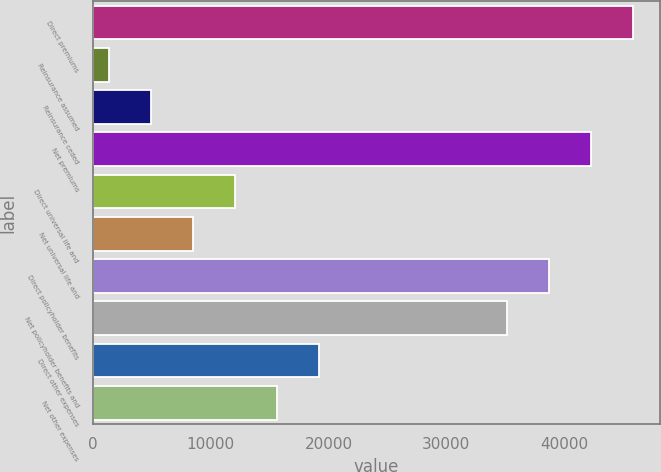Convert chart. <chart><loc_0><loc_0><loc_500><loc_500><bar_chart><fcel>Direct premiums<fcel>Reinsurance assumed<fcel>Reinsurance ceded<fcel>Net premiums<fcel>Direct universal life and<fcel>Net universal life and<fcel>Direct policyholder benefits<fcel>Net policyholder benefits and<fcel>Direct other expenses<fcel>Net other expenses<nl><fcel>45842.6<fcel>1382<fcel>4948.2<fcel>42276.4<fcel>12080.6<fcel>8514.4<fcel>38710.2<fcel>35144<fcel>19213<fcel>15646.8<nl></chart> 